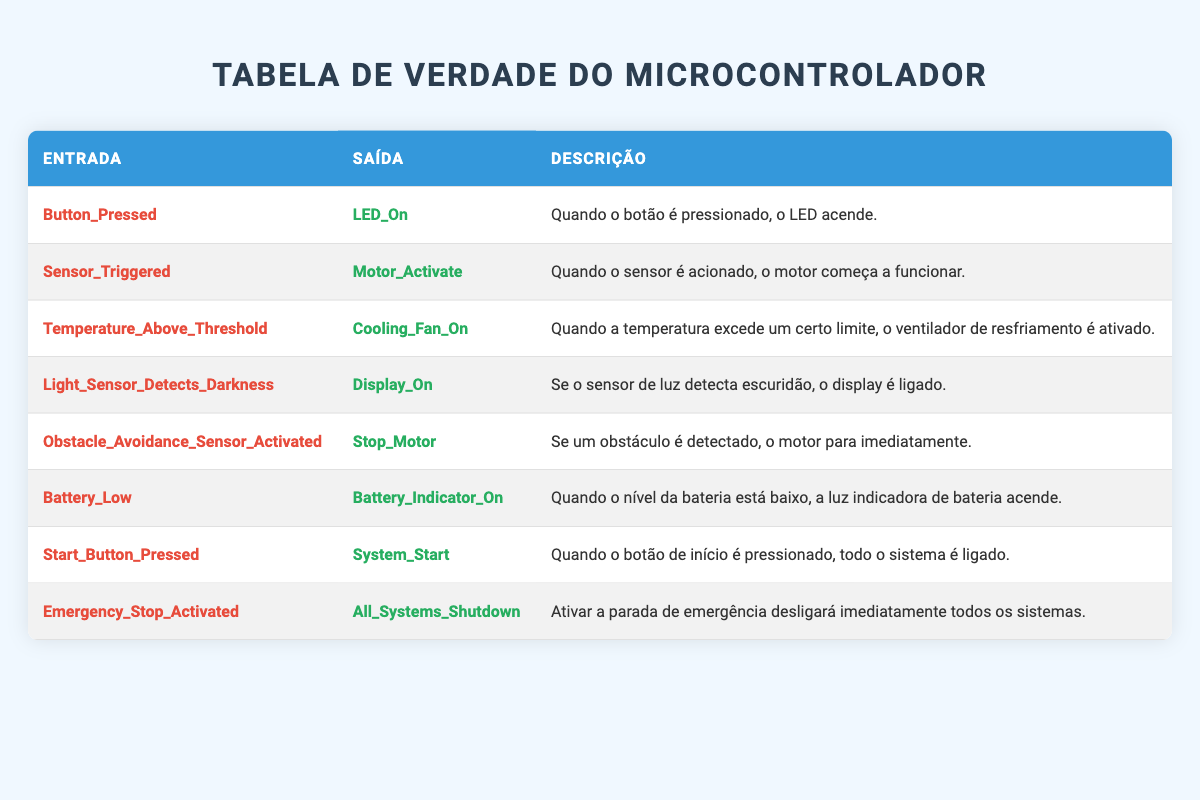Qual é a saída quando o botão é pressionado? A tabela mostra que quando a entrada "Button_Pressed" é ativada, a saída correspondente é "LED_On".
Answer: LED_On O que acontece quando o sensor é acionado? Ao observar a tabela, a entrada "Sensor_Triggered" leva à saída "Motor_Activate", indicando que o motor começa a funcionar.
Answer: Motor_Activate Se a temperatura exceder o limite, qual dispositivo é acionado? De acordo com a tabela, a entrada "Temperature_Above_Threshold" resulta na saída "Cooling_Fan_On", ou seja, o ventilador de resfriamento é ativado.
Answer: Cooling_Fan_On Quando a bateria está baixa, o que ocorre? Ao consultar a tabela, se "Battery_Low" é a entrada, a saída é "Battery_Indicator_On", que significa que a luz indicadora de bateria acende.
Answer: Battery_Indicator_On A ativação da parada de emergência apaga todos os sistemas? A tabela diz que quando "Emergency_Stop_Activated" é acionada, a saída é "All_Systems_Shutdown", confirmando que isso acontece.
Answer: Sim Quantas entradas na tabela resultam em ativação de dispositivos? Há cinco entradas que resultam em ativação de dispositivos: "Motor_Activate", "Cooling_Fan_On", "Display_On", "Battery_Indicator_On" e "System_Start". Portanto, a contagem é 5.
Answer: 5 Se o sensor de luz detecta escuridão, o que acontece? A tabela indica que, com a entrada "Light_Sensor_Detects_Darkness", a saída é "Display_On", significando que o display será ligado.
Answer: Display_On Qual é a relação entre o botão de início e o funcionamento do sistema? A tabela mostra que pressionar "Start_Button_Pressed" resulta em "System_Start", portanto, está diretamente relacionado ao funcionamento de todo o sistema.
Answer: Ligado Quais são as saídas se o motor para imediatamente? De acordo com a tabela, a ativação do "Obstacle_Avoidance_Sensor_Activated" causa "Stop_Motor", o que implica que o motor para imediatamente.
Answer: Stop_Motor Quando a luz indicadora de bateria acende, isso significa que a bateria é suficiente? A tabela indica que a luz "Battery_Indicator_On" se acende apenas quando "Battery_Low" é a entrada, logo, a bateria não é suficiente.
Answer: Não 